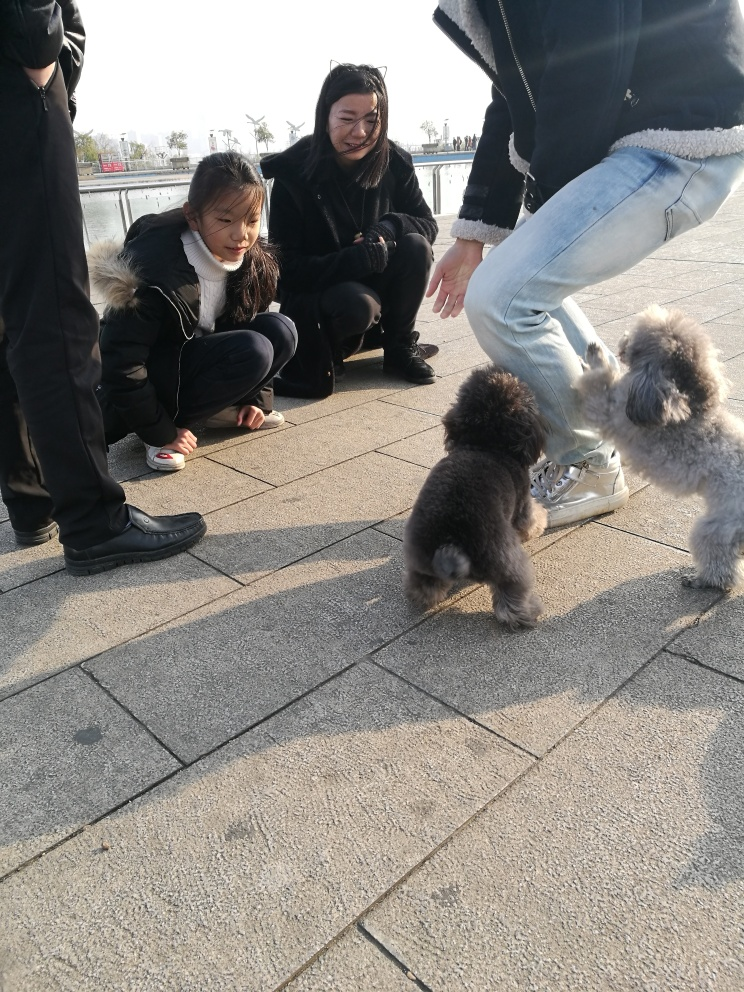Can you tell anything about the dogs' breeds and characteristics? The dogs in the image appear to be of the Poodle breed, discernible by their curly, dense fur and distinctive haircuts. One of the dogs has a darker coat, possibly exhibiting shades of gray or black, while the other is lighter, perhaps white or cream-colored. Both exhibit the signature poise and sociability of Poodles, as they appear very comfortable interacting with the humans around them. 